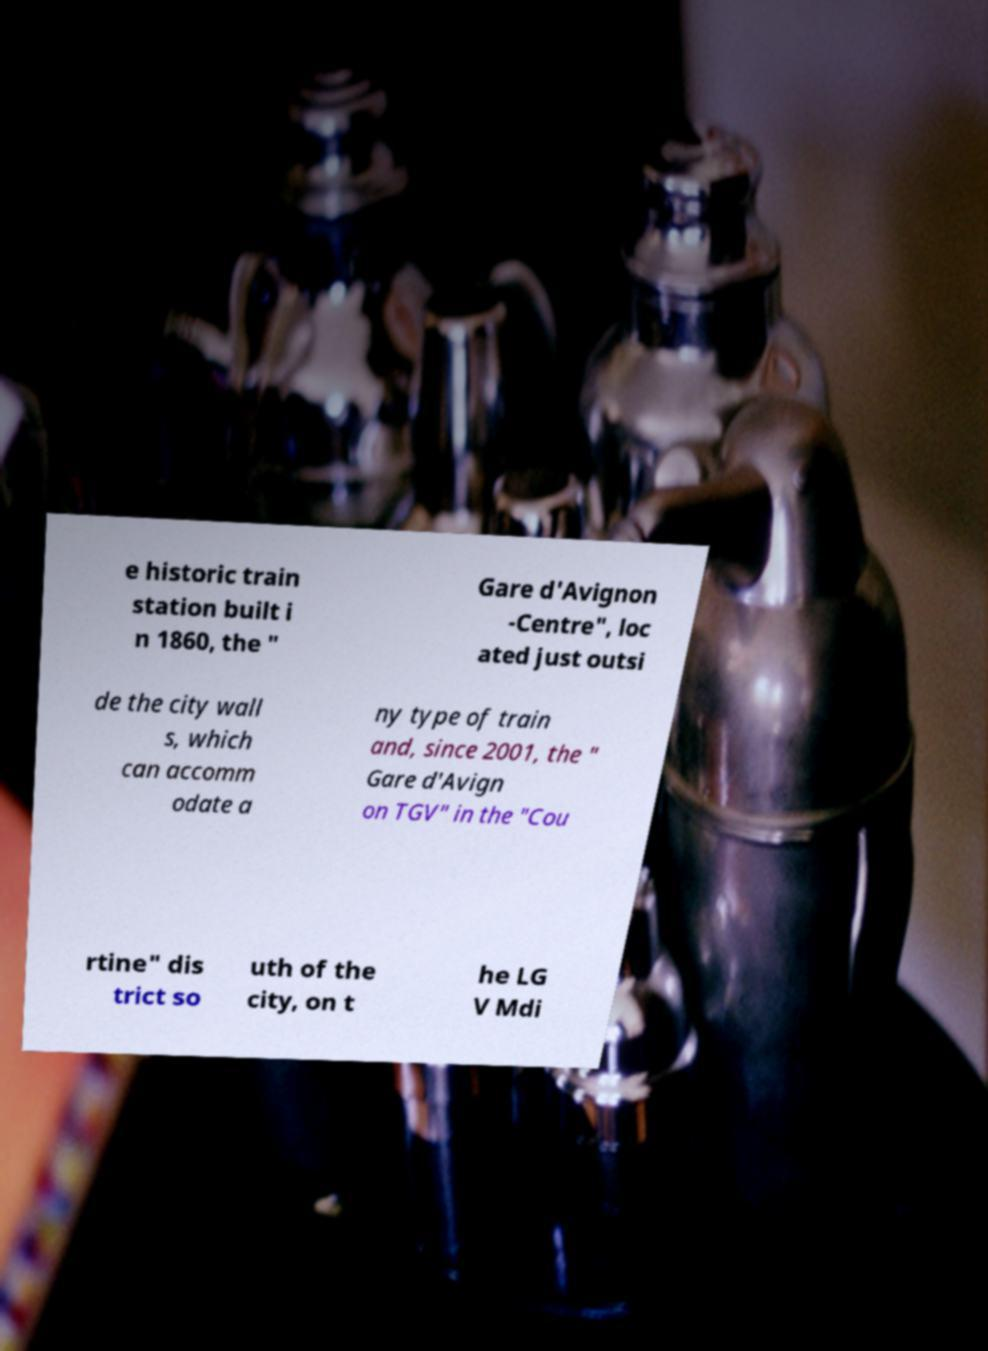Could you assist in decoding the text presented in this image and type it out clearly? e historic train station built i n 1860, the " Gare d'Avignon -Centre", loc ated just outsi de the city wall s, which can accomm odate a ny type of train and, since 2001, the " Gare d'Avign on TGV" in the "Cou rtine" dis trict so uth of the city, on t he LG V Mdi 